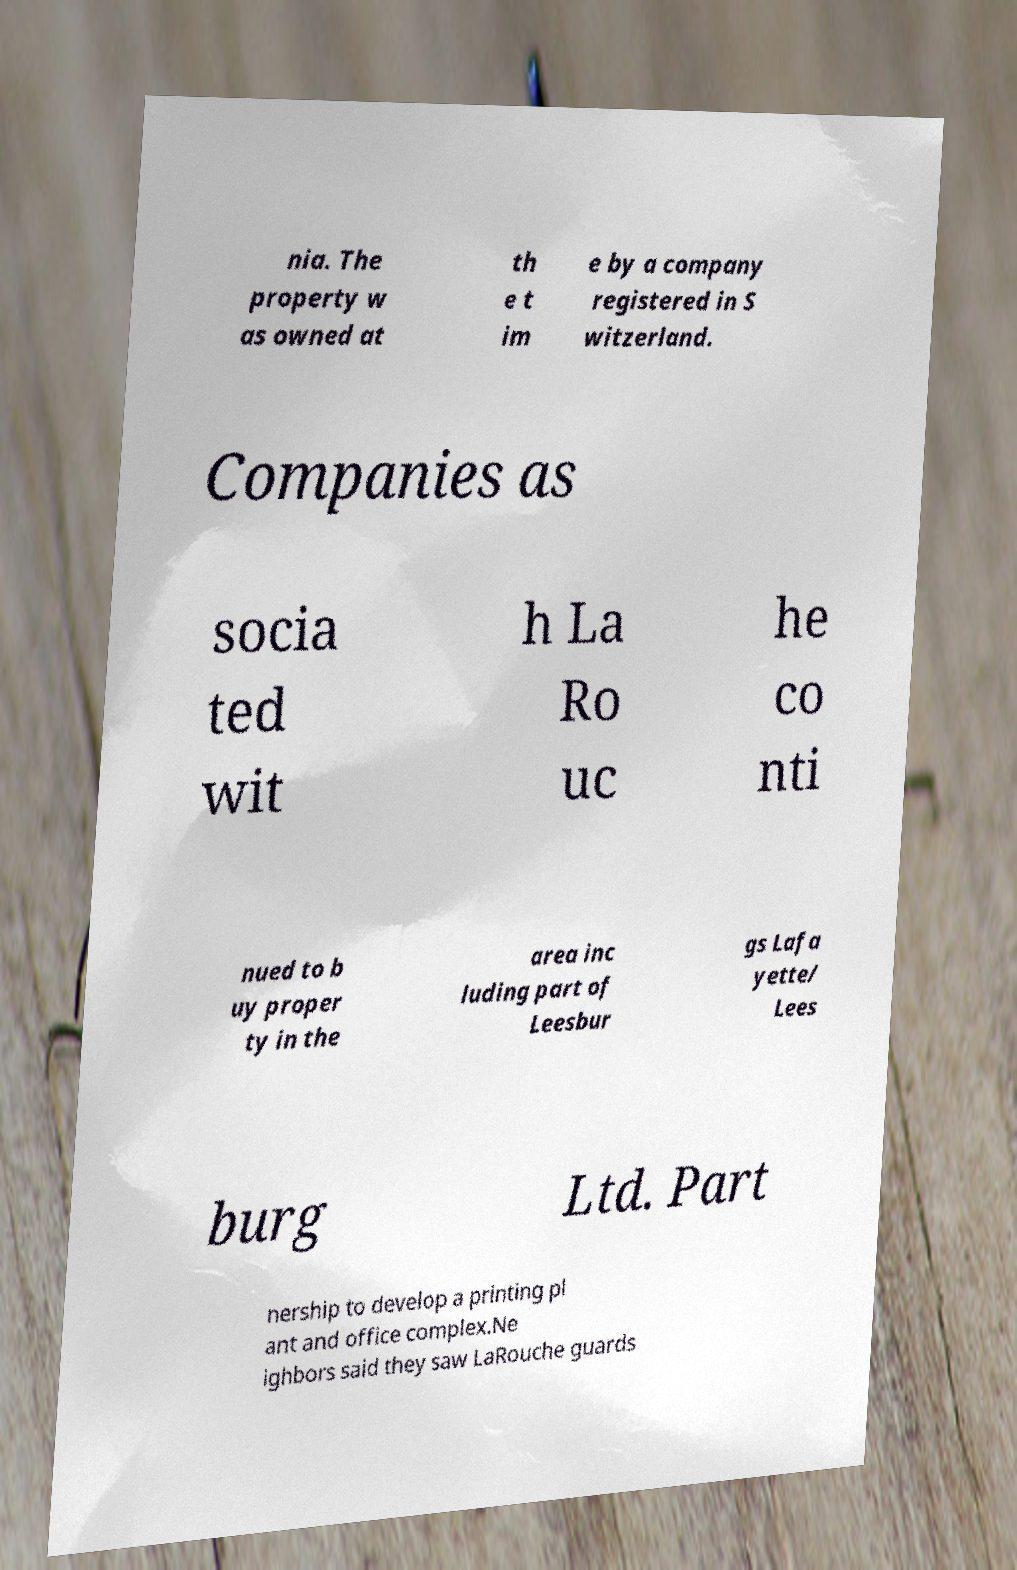There's text embedded in this image that I need extracted. Can you transcribe it verbatim? nia. The property w as owned at th e t im e by a company registered in S witzerland. Companies as socia ted wit h La Ro uc he co nti nued to b uy proper ty in the area inc luding part of Leesbur gs Lafa yette/ Lees burg Ltd. Part nership to develop a printing pl ant and office complex.Ne ighbors said they saw LaRouche guards 